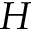<formula> <loc_0><loc_0><loc_500><loc_500>H</formula> 